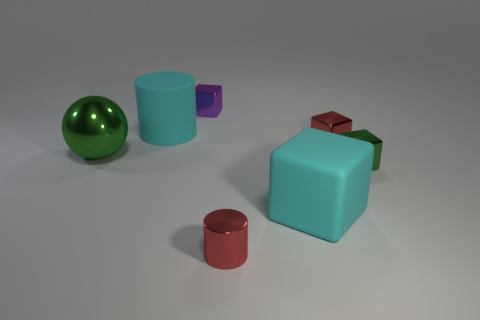There is a small red thing that is in front of the tiny metal cube that is in front of the large ball; what is it made of? The small red object in front of the tiny metal cube, which is itself in front of the large ball, appears to be made of a material that resembles painted metal, based on its reflection and surface texture. 